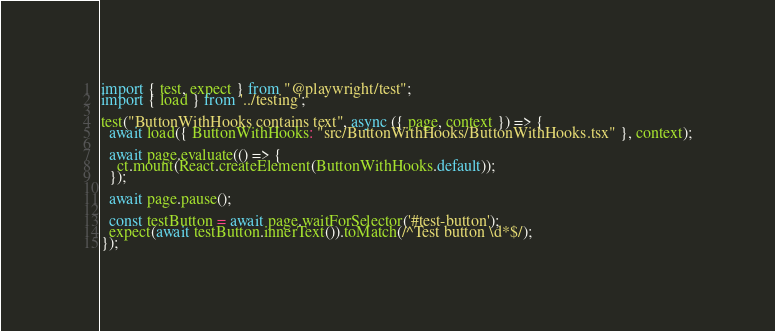Convert code to text. <code><loc_0><loc_0><loc_500><loc_500><_TypeScript_>import { test, expect } from "@playwright/test";
import { load } from '../testing';

test("ButtonWithHooks contains text", async ({ page, context }) => {
  await load({ ButtonWithHooks: "src/ButtonWithHooks/ButtonWithHooks.tsx" }, context);

  await page.evaluate(() => {
    ct.mount(React.createElement(ButtonWithHooks.default));
  });

  await page.pause();

  const testButton = await page.waitForSelector('#test-button');
  expect(await testButton.innerText()).toMatch(/^Test button \d*$/);
});
</code> 